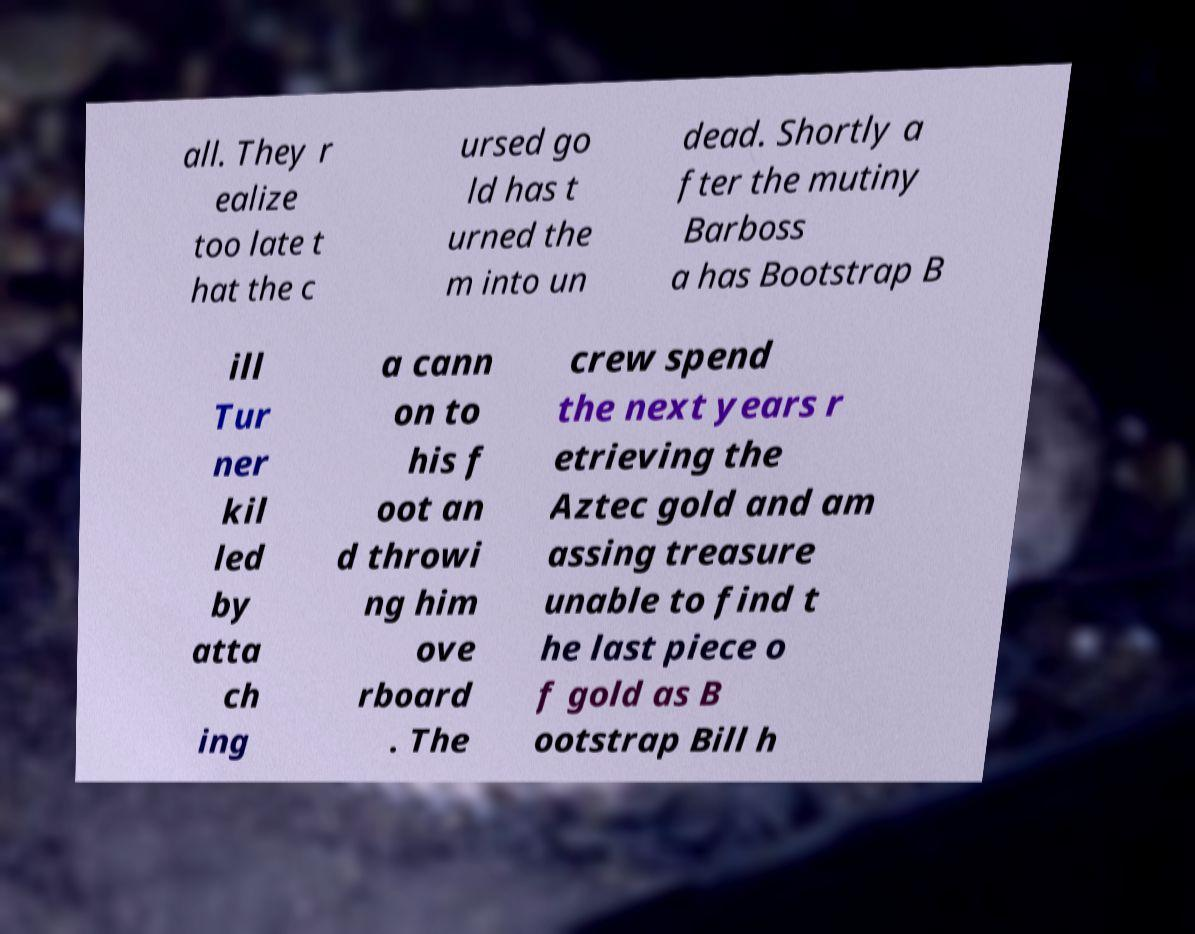Could you assist in decoding the text presented in this image and type it out clearly? all. They r ealize too late t hat the c ursed go ld has t urned the m into un dead. Shortly a fter the mutiny Barboss a has Bootstrap B ill Tur ner kil led by atta ch ing a cann on to his f oot an d throwi ng him ove rboard . The crew spend the next years r etrieving the Aztec gold and am assing treasure unable to find t he last piece o f gold as B ootstrap Bill h 